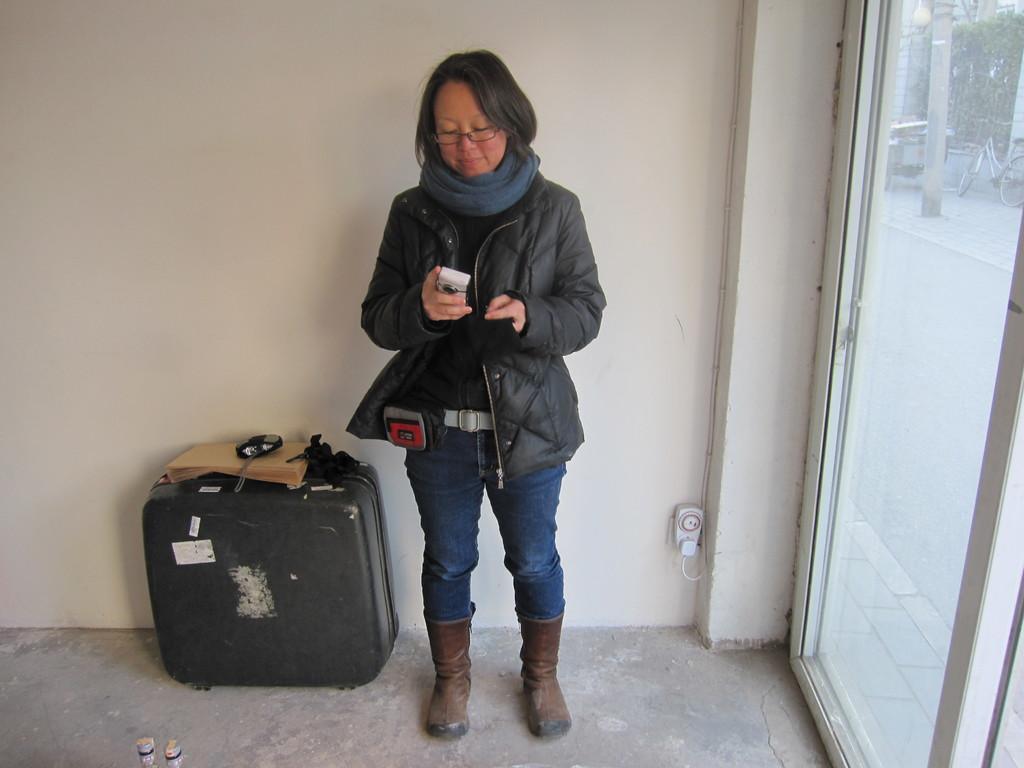How would you summarize this image in a sentence or two? Here we can see a woman is standing on the floor and holding a camera in her hands, and at side their is a briefcase, and at back here is the wall and her is the glass door. 